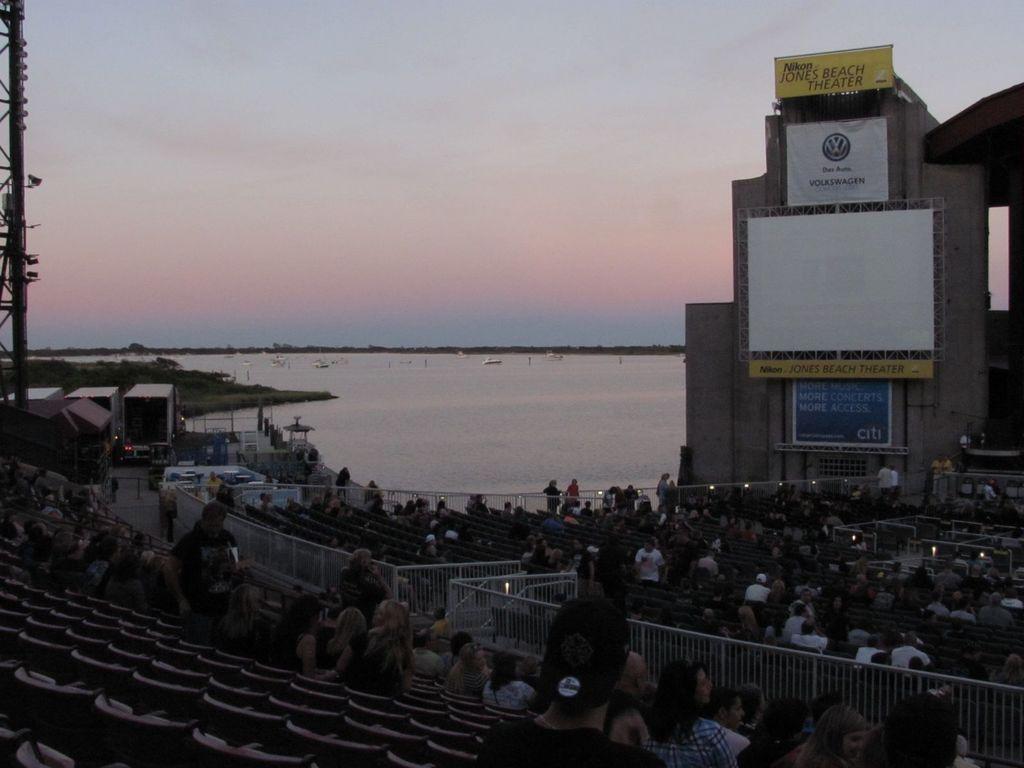Describe this image in one or two sentences. In the given image i can see a building,boards with text,chairs,fence,peoples,grass,water,boats,pole,lights and in the background i can see the sky. 